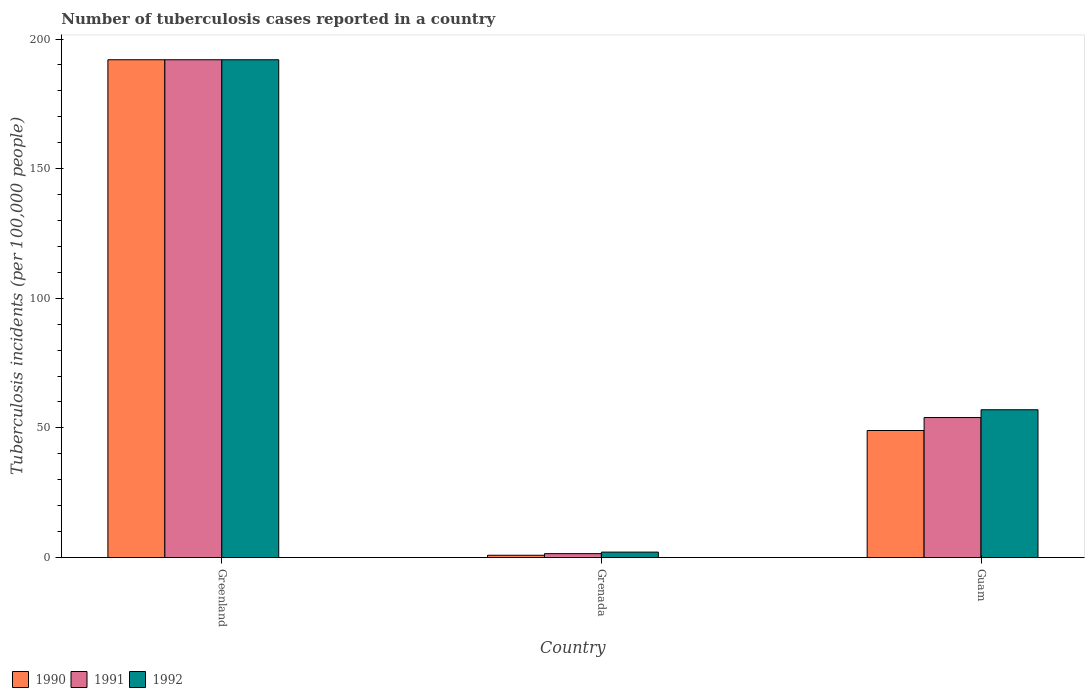How many different coloured bars are there?
Give a very brief answer. 3. How many bars are there on the 2nd tick from the left?
Ensure brevity in your answer.  3. What is the label of the 1st group of bars from the left?
Offer a very short reply. Greenland. What is the number of tuberculosis cases reported in in 1990 in Guam?
Give a very brief answer. 49. Across all countries, what is the maximum number of tuberculosis cases reported in in 1990?
Give a very brief answer. 192. Across all countries, what is the minimum number of tuberculosis cases reported in in 1990?
Provide a succinct answer. 0.88. In which country was the number of tuberculosis cases reported in in 1990 maximum?
Offer a very short reply. Greenland. In which country was the number of tuberculosis cases reported in in 1990 minimum?
Ensure brevity in your answer.  Grenada. What is the total number of tuberculosis cases reported in in 1992 in the graph?
Ensure brevity in your answer.  251.1. What is the difference between the number of tuberculosis cases reported in in 1992 in Greenland and that in Guam?
Your response must be concise. 135. What is the difference between the number of tuberculosis cases reported in in 1992 in Grenada and the number of tuberculosis cases reported in in 1990 in Greenland?
Keep it short and to the point. -189.9. What is the average number of tuberculosis cases reported in in 1990 per country?
Keep it short and to the point. 80.63. What is the difference between the number of tuberculosis cases reported in of/in 1990 and number of tuberculosis cases reported in of/in 1991 in Greenland?
Provide a short and direct response. 0. What is the ratio of the number of tuberculosis cases reported in in 1991 in Grenada to that in Guam?
Your answer should be very brief. 0.03. What is the difference between the highest and the second highest number of tuberculosis cases reported in in 1992?
Your answer should be compact. 135. What is the difference between the highest and the lowest number of tuberculosis cases reported in in 1991?
Offer a terse response. 190.5. Is the sum of the number of tuberculosis cases reported in in 1992 in Greenland and Guam greater than the maximum number of tuberculosis cases reported in in 1991 across all countries?
Offer a terse response. Yes. Does the graph contain any zero values?
Keep it short and to the point. No. Does the graph contain grids?
Make the answer very short. No. What is the title of the graph?
Your answer should be very brief. Number of tuberculosis cases reported in a country. Does "1972" appear as one of the legend labels in the graph?
Provide a succinct answer. No. What is the label or title of the Y-axis?
Your response must be concise. Tuberculosis incidents (per 100,0 people). What is the Tuberculosis incidents (per 100,000 people) of 1990 in Greenland?
Make the answer very short. 192. What is the Tuberculosis incidents (per 100,000 people) in 1991 in Greenland?
Give a very brief answer. 192. What is the Tuberculosis incidents (per 100,000 people) in 1992 in Greenland?
Your answer should be very brief. 192. What is the Tuberculosis incidents (per 100,000 people) of 1991 in Grenada?
Your response must be concise. 1.5. What is the Tuberculosis incidents (per 100,000 people) in 1992 in Grenada?
Provide a short and direct response. 2.1. What is the Tuberculosis incidents (per 100,000 people) in 1991 in Guam?
Ensure brevity in your answer.  54. What is the Tuberculosis incidents (per 100,000 people) of 1992 in Guam?
Provide a succinct answer. 57. Across all countries, what is the maximum Tuberculosis incidents (per 100,000 people) in 1990?
Your response must be concise. 192. Across all countries, what is the maximum Tuberculosis incidents (per 100,000 people) of 1991?
Provide a succinct answer. 192. Across all countries, what is the maximum Tuberculosis incidents (per 100,000 people) in 1992?
Offer a very short reply. 192. Across all countries, what is the minimum Tuberculosis incidents (per 100,000 people) in 1990?
Make the answer very short. 0.88. Across all countries, what is the minimum Tuberculosis incidents (per 100,000 people) of 1991?
Offer a very short reply. 1.5. Across all countries, what is the minimum Tuberculosis incidents (per 100,000 people) in 1992?
Provide a succinct answer. 2.1. What is the total Tuberculosis incidents (per 100,000 people) of 1990 in the graph?
Provide a short and direct response. 241.88. What is the total Tuberculosis incidents (per 100,000 people) in 1991 in the graph?
Keep it short and to the point. 247.5. What is the total Tuberculosis incidents (per 100,000 people) in 1992 in the graph?
Your answer should be compact. 251.1. What is the difference between the Tuberculosis incidents (per 100,000 people) in 1990 in Greenland and that in Grenada?
Ensure brevity in your answer.  191.12. What is the difference between the Tuberculosis incidents (per 100,000 people) in 1991 in Greenland and that in Grenada?
Provide a short and direct response. 190.5. What is the difference between the Tuberculosis incidents (per 100,000 people) of 1992 in Greenland and that in Grenada?
Provide a short and direct response. 189.9. What is the difference between the Tuberculosis incidents (per 100,000 people) of 1990 in Greenland and that in Guam?
Provide a succinct answer. 143. What is the difference between the Tuberculosis incidents (per 100,000 people) in 1991 in Greenland and that in Guam?
Give a very brief answer. 138. What is the difference between the Tuberculosis incidents (per 100,000 people) in 1992 in Greenland and that in Guam?
Your answer should be very brief. 135. What is the difference between the Tuberculosis incidents (per 100,000 people) of 1990 in Grenada and that in Guam?
Make the answer very short. -48.12. What is the difference between the Tuberculosis incidents (per 100,000 people) of 1991 in Grenada and that in Guam?
Provide a succinct answer. -52.5. What is the difference between the Tuberculosis incidents (per 100,000 people) in 1992 in Grenada and that in Guam?
Your response must be concise. -54.9. What is the difference between the Tuberculosis incidents (per 100,000 people) of 1990 in Greenland and the Tuberculosis incidents (per 100,000 people) of 1991 in Grenada?
Give a very brief answer. 190.5. What is the difference between the Tuberculosis incidents (per 100,000 people) of 1990 in Greenland and the Tuberculosis incidents (per 100,000 people) of 1992 in Grenada?
Give a very brief answer. 189.9. What is the difference between the Tuberculosis incidents (per 100,000 people) in 1991 in Greenland and the Tuberculosis incidents (per 100,000 people) in 1992 in Grenada?
Offer a terse response. 189.9. What is the difference between the Tuberculosis incidents (per 100,000 people) of 1990 in Greenland and the Tuberculosis incidents (per 100,000 people) of 1991 in Guam?
Your response must be concise. 138. What is the difference between the Tuberculosis incidents (per 100,000 people) in 1990 in Greenland and the Tuberculosis incidents (per 100,000 people) in 1992 in Guam?
Give a very brief answer. 135. What is the difference between the Tuberculosis incidents (per 100,000 people) in 1991 in Greenland and the Tuberculosis incidents (per 100,000 people) in 1992 in Guam?
Keep it short and to the point. 135. What is the difference between the Tuberculosis incidents (per 100,000 people) of 1990 in Grenada and the Tuberculosis incidents (per 100,000 people) of 1991 in Guam?
Give a very brief answer. -53.12. What is the difference between the Tuberculosis incidents (per 100,000 people) of 1990 in Grenada and the Tuberculosis incidents (per 100,000 people) of 1992 in Guam?
Your response must be concise. -56.12. What is the difference between the Tuberculosis incidents (per 100,000 people) of 1991 in Grenada and the Tuberculosis incidents (per 100,000 people) of 1992 in Guam?
Your answer should be very brief. -55.5. What is the average Tuberculosis incidents (per 100,000 people) of 1990 per country?
Give a very brief answer. 80.63. What is the average Tuberculosis incidents (per 100,000 people) in 1991 per country?
Keep it short and to the point. 82.5. What is the average Tuberculosis incidents (per 100,000 people) of 1992 per country?
Provide a succinct answer. 83.7. What is the difference between the Tuberculosis incidents (per 100,000 people) of 1990 and Tuberculosis incidents (per 100,000 people) of 1991 in Grenada?
Offer a terse response. -0.62. What is the difference between the Tuberculosis incidents (per 100,000 people) of 1990 and Tuberculosis incidents (per 100,000 people) of 1992 in Grenada?
Make the answer very short. -1.22. What is the difference between the Tuberculosis incidents (per 100,000 people) in 1990 and Tuberculosis incidents (per 100,000 people) in 1992 in Guam?
Make the answer very short. -8. What is the difference between the Tuberculosis incidents (per 100,000 people) in 1991 and Tuberculosis incidents (per 100,000 people) in 1992 in Guam?
Keep it short and to the point. -3. What is the ratio of the Tuberculosis incidents (per 100,000 people) in 1990 in Greenland to that in Grenada?
Keep it short and to the point. 218.18. What is the ratio of the Tuberculosis incidents (per 100,000 people) in 1991 in Greenland to that in Grenada?
Ensure brevity in your answer.  128. What is the ratio of the Tuberculosis incidents (per 100,000 people) of 1992 in Greenland to that in Grenada?
Provide a short and direct response. 91.43. What is the ratio of the Tuberculosis incidents (per 100,000 people) of 1990 in Greenland to that in Guam?
Keep it short and to the point. 3.92. What is the ratio of the Tuberculosis incidents (per 100,000 people) of 1991 in Greenland to that in Guam?
Provide a short and direct response. 3.56. What is the ratio of the Tuberculosis incidents (per 100,000 people) in 1992 in Greenland to that in Guam?
Make the answer very short. 3.37. What is the ratio of the Tuberculosis incidents (per 100,000 people) in 1990 in Grenada to that in Guam?
Offer a terse response. 0.02. What is the ratio of the Tuberculosis incidents (per 100,000 people) in 1991 in Grenada to that in Guam?
Give a very brief answer. 0.03. What is the ratio of the Tuberculosis incidents (per 100,000 people) of 1992 in Grenada to that in Guam?
Provide a succinct answer. 0.04. What is the difference between the highest and the second highest Tuberculosis incidents (per 100,000 people) of 1990?
Give a very brief answer. 143. What is the difference between the highest and the second highest Tuberculosis incidents (per 100,000 people) of 1991?
Your response must be concise. 138. What is the difference between the highest and the second highest Tuberculosis incidents (per 100,000 people) in 1992?
Provide a short and direct response. 135. What is the difference between the highest and the lowest Tuberculosis incidents (per 100,000 people) in 1990?
Keep it short and to the point. 191.12. What is the difference between the highest and the lowest Tuberculosis incidents (per 100,000 people) in 1991?
Your answer should be compact. 190.5. What is the difference between the highest and the lowest Tuberculosis incidents (per 100,000 people) of 1992?
Make the answer very short. 189.9. 